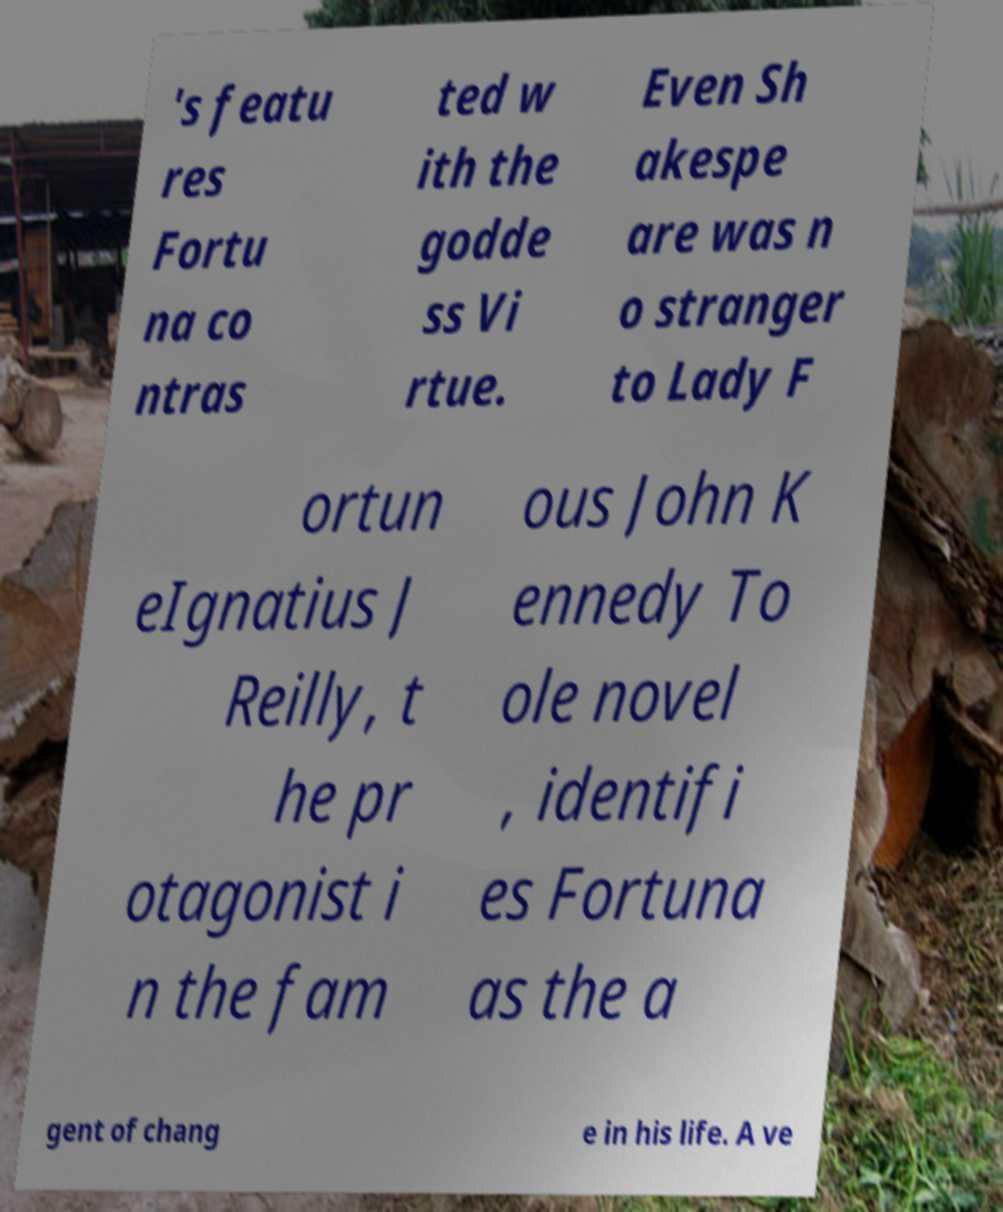Please identify and transcribe the text found in this image. 's featu res Fortu na co ntras ted w ith the godde ss Vi rtue. Even Sh akespe are was n o stranger to Lady F ortun eIgnatius J Reilly, t he pr otagonist i n the fam ous John K ennedy To ole novel , identifi es Fortuna as the a gent of chang e in his life. A ve 